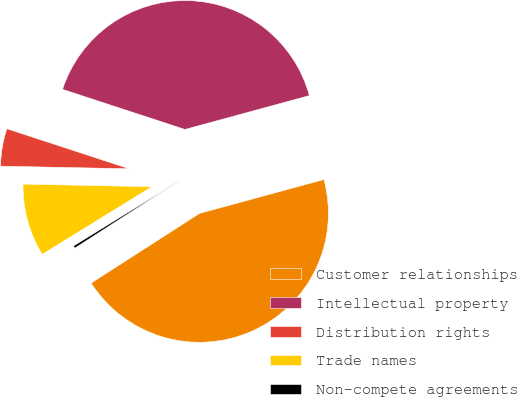Convert chart. <chart><loc_0><loc_0><loc_500><loc_500><pie_chart><fcel>Customer relationships<fcel>Intellectual property<fcel>Distribution rights<fcel>Trade names<fcel>Non-compete agreements<nl><fcel>45.13%<fcel>40.73%<fcel>4.71%<fcel>9.11%<fcel>0.31%<nl></chart> 